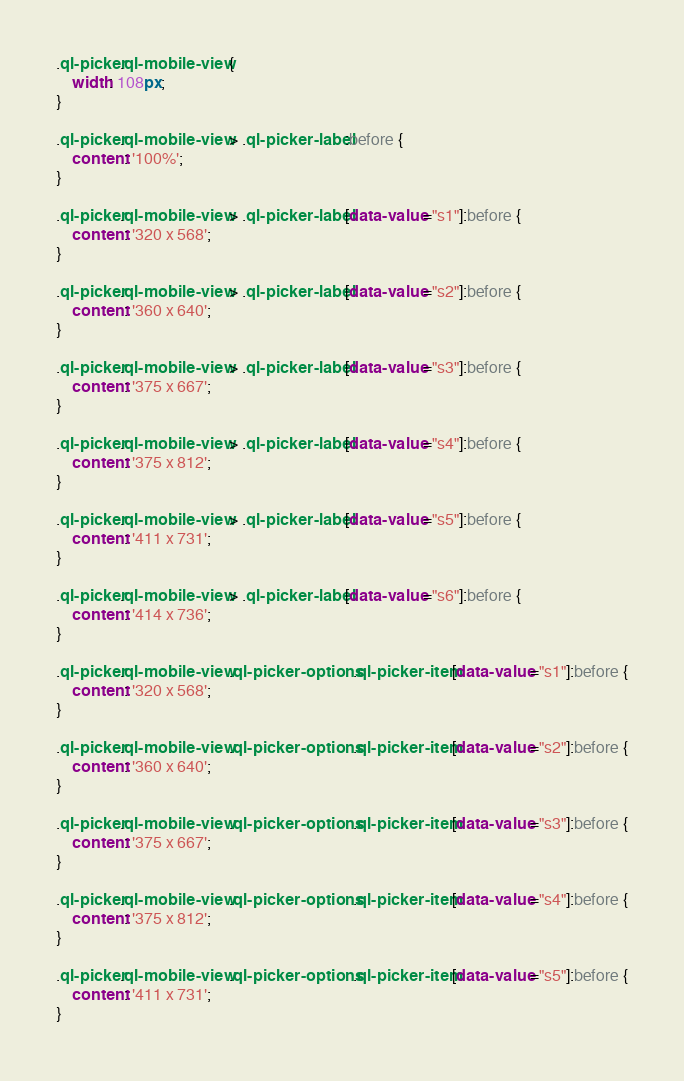<code> <loc_0><loc_0><loc_500><loc_500><_CSS_>.ql-picker.ql-mobile-view {
    width: 108px;
}

.ql-picker.ql-mobile-view > .ql-picker-label:before {
    content: '100%';
}

.ql-picker.ql-mobile-view > .ql-picker-label[data-value="s1"]:before {
    content: '320 x 568';
}

.ql-picker.ql-mobile-view > .ql-picker-label[data-value="s2"]:before {
    content: '360 x 640';
}

.ql-picker.ql-mobile-view > .ql-picker-label[data-value="s3"]:before {
    content: '375 x 667';
}

.ql-picker.ql-mobile-view > .ql-picker-label[data-value="s4"]:before {
    content: '375 x 812';
}

.ql-picker.ql-mobile-view > .ql-picker-label[data-value="s5"]:before {
    content: '411 x 731';
}

.ql-picker.ql-mobile-view > .ql-picker-label[data-value="s6"]:before {
    content: '414 x 736';
}

.ql-picker.ql-mobile-view .ql-picker-options .ql-picker-item[data-value="s1"]:before {
    content: '320 x 568';
}

.ql-picker.ql-mobile-view .ql-picker-options .ql-picker-item[data-value="s2"]:before {
    content: '360 x 640';
}

.ql-picker.ql-mobile-view .ql-picker-options .ql-picker-item[data-value="s3"]:before {
    content: '375 x 667';
}

.ql-picker.ql-mobile-view .ql-picker-options .ql-picker-item[data-value="s4"]:before {
    content: '375 x 812';
}

.ql-picker.ql-mobile-view .ql-picker-options .ql-picker-item[data-value="s5"]:before {
    content: '411 x 731';
}
</code> 